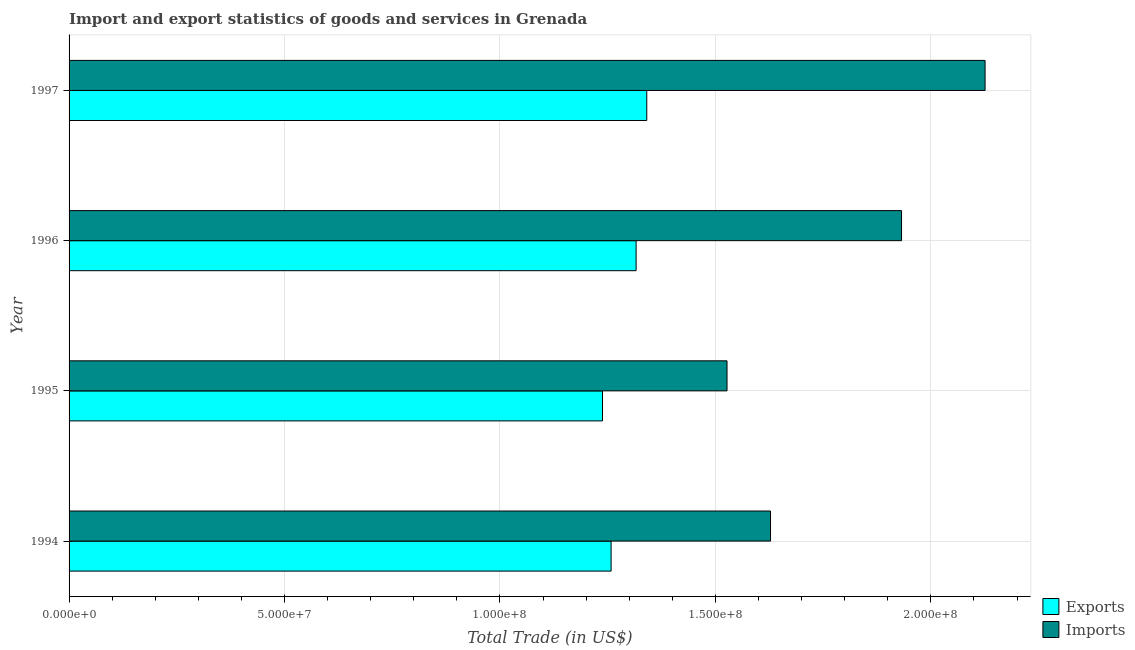Are the number of bars per tick equal to the number of legend labels?
Give a very brief answer. Yes. How many bars are there on the 4th tick from the bottom?
Your response must be concise. 2. What is the label of the 1st group of bars from the top?
Your answer should be compact. 1997. What is the export of goods and services in 1996?
Give a very brief answer. 1.32e+08. Across all years, what is the maximum imports of goods and services?
Give a very brief answer. 2.13e+08. Across all years, what is the minimum imports of goods and services?
Offer a terse response. 1.53e+08. In which year was the imports of goods and services maximum?
Provide a short and direct response. 1997. What is the total export of goods and services in the graph?
Keep it short and to the point. 5.15e+08. What is the difference between the export of goods and services in 1995 and that in 1997?
Keep it short and to the point. -1.03e+07. What is the difference between the export of goods and services in 1995 and the imports of goods and services in 1994?
Ensure brevity in your answer.  -3.90e+07. What is the average imports of goods and services per year?
Provide a short and direct response. 1.80e+08. In the year 1994, what is the difference between the imports of goods and services and export of goods and services?
Make the answer very short. 3.70e+07. What is the ratio of the export of goods and services in 1996 to that in 1997?
Provide a succinct answer. 0.98. Is the export of goods and services in 1994 less than that in 1997?
Keep it short and to the point. Yes. Is the difference between the export of goods and services in 1996 and 1997 greater than the difference between the imports of goods and services in 1996 and 1997?
Provide a short and direct response. Yes. What is the difference between the highest and the second highest export of goods and services?
Your response must be concise. 2.47e+06. What is the difference between the highest and the lowest imports of goods and services?
Your answer should be very brief. 5.99e+07. Is the sum of the imports of goods and services in 1994 and 1997 greater than the maximum export of goods and services across all years?
Ensure brevity in your answer.  Yes. What does the 2nd bar from the top in 1997 represents?
Your answer should be compact. Exports. What does the 2nd bar from the bottom in 1997 represents?
Your answer should be very brief. Imports. Are all the bars in the graph horizontal?
Make the answer very short. Yes. How many years are there in the graph?
Make the answer very short. 4. Does the graph contain grids?
Make the answer very short. Yes. How are the legend labels stacked?
Offer a terse response. Vertical. What is the title of the graph?
Provide a succinct answer. Import and export statistics of goods and services in Grenada. Does "Official aid received" appear as one of the legend labels in the graph?
Your answer should be compact. No. What is the label or title of the X-axis?
Provide a short and direct response. Total Trade (in US$). What is the label or title of the Y-axis?
Provide a succinct answer. Year. What is the Total Trade (in US$) in Exports in 1994?
Your answer should be very brief. 1.26e+08. What is the Total Trade (in US$) in Imports in 1994?
Offer a very short reply. 1.63e+08. What is the Total Trade (in US$) of Exports in 1995?
Provide a succinct answer. 1.24e+08. What is the Total Trade (in US$) in Imports in 1995?
Your response must be concise. 1.53e+08. What is the Total Trade (in US$) in Exports in 1996?
Ensure brevity in your answer.  1.32e+08. What is the Total Trade (in US$) in Imports in 1996?
Your answer should be compact. 1.93e+08. What is the Total Trade (in US$) of Exports in 1997?
Offer a terse response. 1.34e+08. What is the Total Trade (in US$) of Imports in 1997?
Provide a succinct answer. 2.13e+08. Across all years, what is the maximum Total Trade (in US$) of Exports?
Offer a very short reply. 1.34e+08. Across all years, what is the maximum Total Trade (in US$) in Imports?
Give a very brief answer. 2.13e+08. Across all years, what is the minimum Total Trade (in US$) in Exports?
Your answer should be very brief. 1.24e+08. Across all years, what is the minimum Total Trade (in US$) of Imports?
Ensure brevity in your answer.  1.53e+08. What is the total Total Trade (in US$) in Exports in the graph?
Provide a succinct answer. 5.15e+08. What is the total Total Trade (in US$) of Imports in the graph?
Ensure brevity in your answer.  7.21e+08. What is the difference between the Total Trade (in US$) in Imports in 1994 and that in 1995?
Ensure brevity in your answer.  1.01e+07. What is the difference between the Total Trade (in US$) of Exports in 1994 and that in 1996?
Ensure brevity in your answer.  -5.80e+06. What is the difference between the Total Trade (in US$) in Imports in 1994 and that in 1996?
Provide a succinct answer. -3.04e+07. What is the difference between the Total Trade (in US$) in Exports in 1994 and that in 1997?
Keep it short and to the point. -8.27e+06. What is the difference between the Total Trade (in US$) of Imports in 1994 and that in 1997?
Your answer should be very brief. -4.98e+07. What is the difference between the Total Trade (in US$) of Exports in 1995 and that in 1996?
Offer a very short reply. -7.80e+06. What is the difference between the Total Trade (in US$) of Imports in 1995 and that in 1996?
Offer a very short reply. -4.05e+07. What is the difference between the Total Trade (in US$) of Exports in 1995 and that in 1997?
Offer a terse response. -1.03e+07. What is the difference between the Total Trade (in US$) in Imports in 1995 and that in 1997?
Provide a short and direct response. -5.99e+07. What is the difference between the Total Trade (in US$) of Exports in 1996 and that in 1997?
Provide a short and direct response. -2.47e+06. What is the difference between the Total Trade (in US$) in Imports in 1996 and that in 1997?
Ensure brevity in your answer.  -1.94e+07. What is the difference between the Total Trade (in US$) in Exports in 1994 and the Total Trade (in US$) in Imports in 1995?
Ensure brevity in your answer.  -2.69e+07. What is the difference between the Total Trade (in US$) of Exports in 1994 and the Total Trade (in US$) of Imports in 1996?
Ensure brevity in your answer.  -6.74e+07. What is the difference between the Total Trade (in US$) in Exports in 1994 and the Total Trade (in US$) in Imports in 1997?
Offer a terse response. -8.68e+07. What is the difference between the Total Trade (in US$) in Exports in 1995 and the Total Trade (in US$) in Imports in 1996?
Ensure brevity in your answer.  -6.94e+07. What is the difference between the Total Trade (in US$) of Exports in 1995 and the Total Trade (in US$) of Imports in 1997?
Provide a short and direct response. -8.88e+07. What is the difference between the Total Trade (in US$) in Exports in 1996 and the Total Trade (in US$) in Imports in 1997?
Ensure brevity in your answer.  -8.10e+07. What is the average Total Trade (in US$) of Exports per year?
Keep it short and to the point. 1.29e+08. What is the average Total Trade (in US$) in Imports per year?
Offer a terse response. 1.80e+08. In the year 1994, what is the difference between the Total Trade (in US$) in Exports and Total Trade (in US$) in Imports?
Your answer should be very brief. -3.70e+07. In the year 1995, what is the difference between the Total Trade (in US$) in Exports and Total Trade (in US$) in Imports?
Make the answer very short. -2.89e+07. In the year 1996, what is the difference between the Total Trade (in US$) in Exports and Total Trade (in US$) in Imports?
Make the answer very short. -6.16e+07. In the year 1997, what is the difference between the Total Trade (in US$) of Exports and Total Trade (in US$) of Imports?
Keep it short and to the point. -7.85e+07. What is the ratio of the Total Trade (in US$) of Exports in 1994 to that in 1995?
Provide a short and direct response. 1.02. What is the ratio of the Total Trade (in US$) of Imports in 1994 to that in 1995?
Keep it short and to the point. 1.07. What is the ratio of the Total Trade (in US$) in Exports in 1994 to that in 1996?
Ensure brevity in your answer.  0.96. What is the ratio of the Total Trade (in US$) in Imports in 1994 to that in 1996?
Make the answer very short. 0.84. What is the ratio of the Total Trade (in US$) of Exports in 1994 to that in 1997?
Give a very brief answer. 0.94. What is the ratio of the Total Trade (in US$) of Imports in 1994 to that in 1997?
Your answer should be very brief. 0.77. What is the ratio of the Total Trade (in US$) in Exports in 1995 to that in 1996?
Provide a succinct answer. 0.94. What is the ratio of the Total Trade (in US$) of Imports in 1995 to that in 1996?
Provide a succinct answer. 0.79. What is the ratio of the Total Trade (in US$) in Exports in 1995 to that in 1997?
Offer a very short reply. 0.92. What is the ratio of the Total Trade (in US$) in Imports in 1995 to that in 1997?
Give a very brief answer. 0.72. What is the ratio of the Total Trade (in US$) in Exports in 1996 to that in 1997?
Your answer should be compact. 0.98. What is the ratio of the Total Trade (in US$) of Imports in 1996 to that in 1997?
Offer a very short reply. 0.91. What is the difference between the highest and the second highest Total Trade (in US$) in Exports?
Give a very brief answer. 2.47e+06. What is the difference between the highest and the second highest Total Trade (in US$) of Imports?
Ensure brevity in your answer.  1.94e+07. What is the difference between the highest and the lowest Total Trade (in US$) of Exports?
Offer a very short reply. 1.03e+07. What is the difference between the highest and the lowest Total Trade (in US$) of Imports?
Make the answer very short. 5.99e+07. 